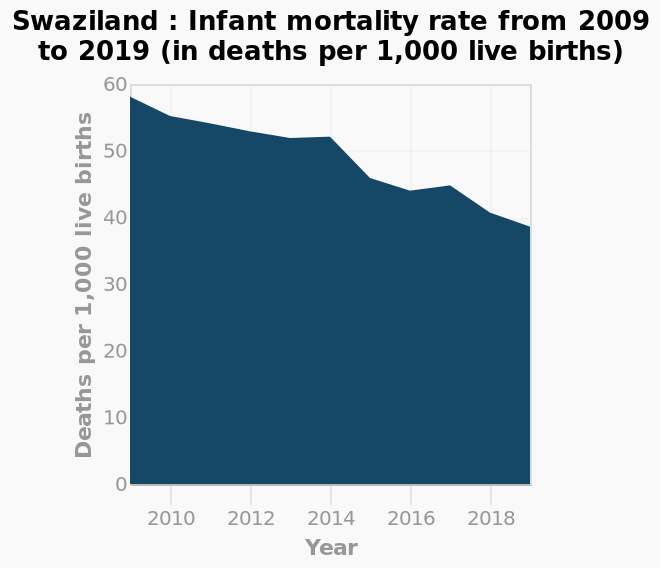<image>
Were there any spikes in the rate of infant mortality per 1000 births in Swaziland after 2009? Yes, there were spikes in the rate of infant mortality per 1000 births in Swaziland in 2014 and 2017. What is the range of the y-axis in the area graph? The y-axis ranges from 0 to 60 deaths per 1,000 live births. Offer a thorough analysis of the image. The infant mortality rate has decreased from 2009 to 2019. It occasionally increased compared to the previous year but overall decreased. Describe the following image in detail Swaziland : Infant mortality rate from 2009 to 2019 (in deaths per 1,000 live births) is a area graph. The y-axis plots Deaths per 1,000 live births with linear scale with a minimum of 0 and a maximum of 60 while the x-axis shows Year as linear scale with a minimum of 2010 and a maximum of 2018. 